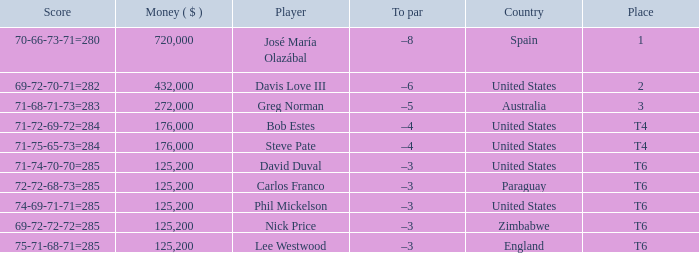Which Score has a Place of 3? 71-68-71-73=283. 